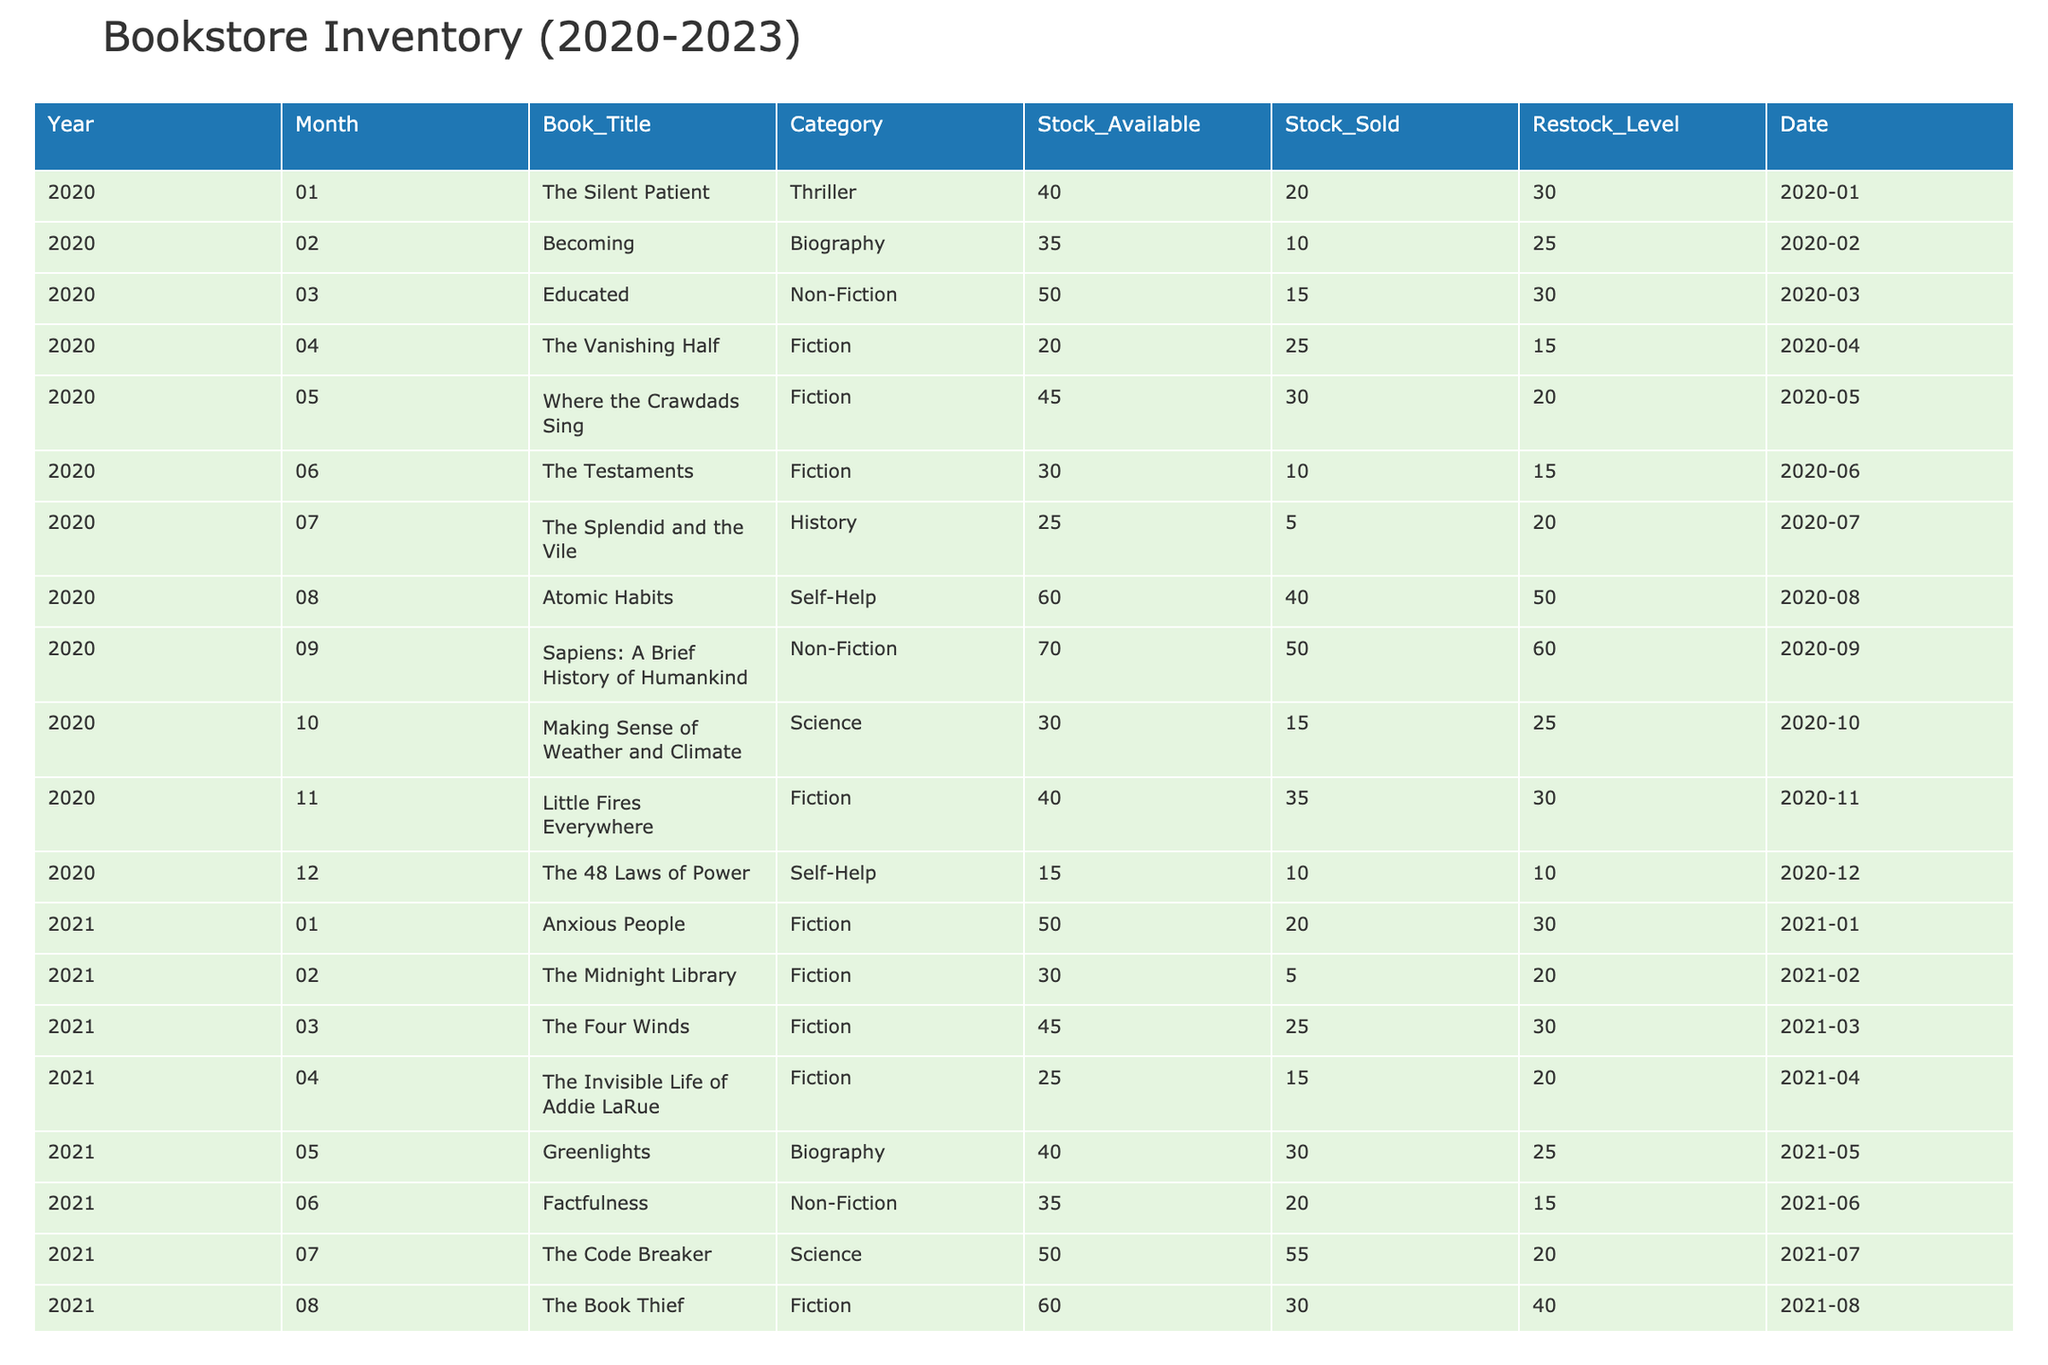What was the stock sold for "Where the Crawdads Sing" in May 2020? In the row for May 2020, the stock sold for "Where the Crawdads Sing" is listed as 30.
Answer: 30 Which month had the highest stock available in 2022? In 2022, the highest stock available is 60, which occurred in September for "Hands-On Machine Learning."
Answer: September What is the total stock sold for the category 'Data Science' from 2020 to 2023? The stock sold for Data Science books for each year is as follows: in 2020 = 0, 2021 = 0, 2022 = 75 (10 + 15 + 10 + 40) and in 2023 = 100 (15 + 20 + 35 + 5 + 20), totaling 175 (0 + 0 + 75 + 100).
Answer: 175 Did "The Midnight Library" sell more than 10 copies in February 2021? In February 2021, "The Midnight Library" sold only 5 copies, which is less than 10.
Answer: No Which book had the lowest stock available in the year 2023? In 2023, the book with the lowest stock available is "Data-Driven Science and Engineering" with 20 copies.
Answer: 20 What was the average stock sold in June for the years 2020 to 2023? The stock sold in June for respective years is: 10 (2020), 55 (2021), 15 (2022), 10 (2023). Summing these gives 90, dividing by 4 yields an average of 22.5.
Answer: 22.5 What percentage of the stock available was sold for "Making Sense of Weather and Climate" in October 2020? The stock available for "Making Sense of Weather and Climate" is 30, and the stock sold was 15. The percentage sold is calculated as (15/30)*100 = 50%.
Answer: 50% Which category had the most items in stock available in 2020? In 2020, the category with the most items in stock was 'Fiction', with a maximum stock of 60 (in August for "Atomic Habits").
Answer: Fiction 